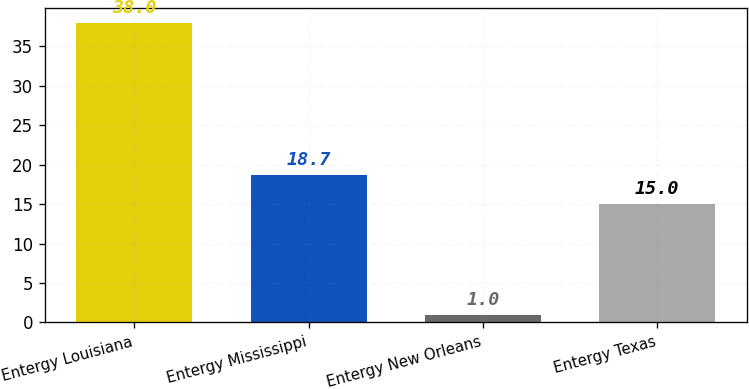Convert chart to OTSL. <chart><loc_0><loc_0><loc_500><loc_500><bar_chart><fcel>Entergy Louisiana<fcel>Entergy Mississippi<fcel>Entergy New Orleans<fcel>Entergy Texas<nl><fcel>38<fcel>18.7<fcel>1<fcel>15<nl></chart> 